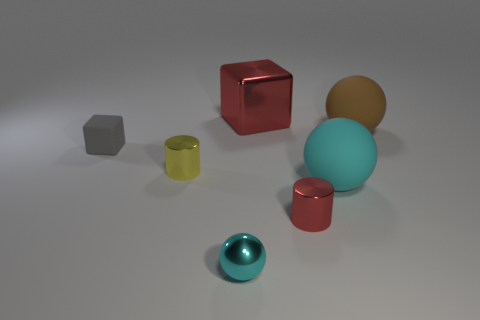What shape is the large rubber thing that is the same color as the tiny sphere?
Keep it short and to the point. Sphere. How many objects are both in front of the small yellow object and to the right of the red cylinder?
Provide a short and direct response. 1. Are there any tiny gray blocks that have the same material as the large red block?
Offer a very short reply. No. What is the size of the metallic cylinder that is the same color as the large block?
Ensure brevity in your answer.  Small. How many cylinders are cyan rubber things or tiny red things?
Keep it short and to the point. 1. The red metal block is what size?
Keep it short and to the point. Large. How many cyan things are on the left side of the small cyan metallic object?
Ensure brevity in your answer.  0. There is a red shiny thing that is in front of the cube that is to the left of the red metallic cube; what size is it?
Ensure brevity in your answer.  Small. There is a big cyan matte thing that is to the right of the gray block; is its shape the same as the red metallic object that is behind the small gray matte thing?
Give a very brief answer. No. What is the shape of the big matte object on the right side of the large matte sphere that is in front of the gray cube?
Offer a very short reply. Sphere. 